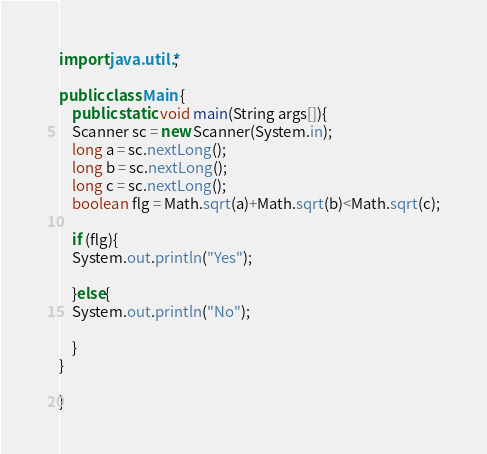Convert code to text. <code><loc_0><loc_0><loc_500><loc_500><_Java_>import java.util.*;

public class Main {
	public static void main(String args[]){
    Scanner sc = new Scanner(System.in);
    long a = sc.nextLong();
    long b = sc.nextLong();
    long c = sc.nextLong();
    boolean flg = Math.sqrt(a)+Math.sqrt(b)<Math.sqrt(c);

    if (flg){
    System.out.println("Yes");

    }else{
    System.out.println("No");

    }
}

}</code> 